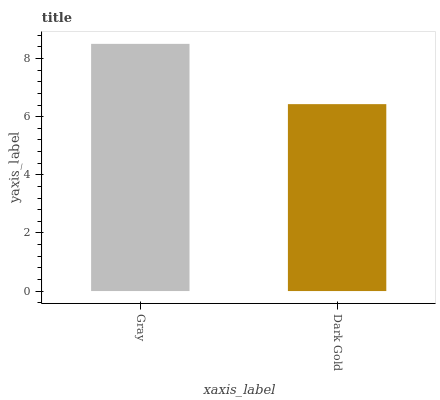Is Dark Gold the minimum?
Answer yes or no. Yes. Is Gray the maximum?
Answer yes or no. Yes. Is Dark Gold the maximum?
Answer yes or no. No. Is Gray greater than Dark Gold?
Answer yes or no. Yes. Is Dark Gold less than Gray?
Answer yes or no. Yes. Is Dark Gold greater than Gray?
Answer yes or no. No. Is Gray less than Dark Gold?
Answer yes or no. No. Is Gray the high median?
Answer yes or no. Yes. Is Dark Gold the low median?
Answer yes or no. Yes. Is Dark Gold the high median?
Answer yes or no. No. Is Gray the low median?
Answer yes or no. No. 